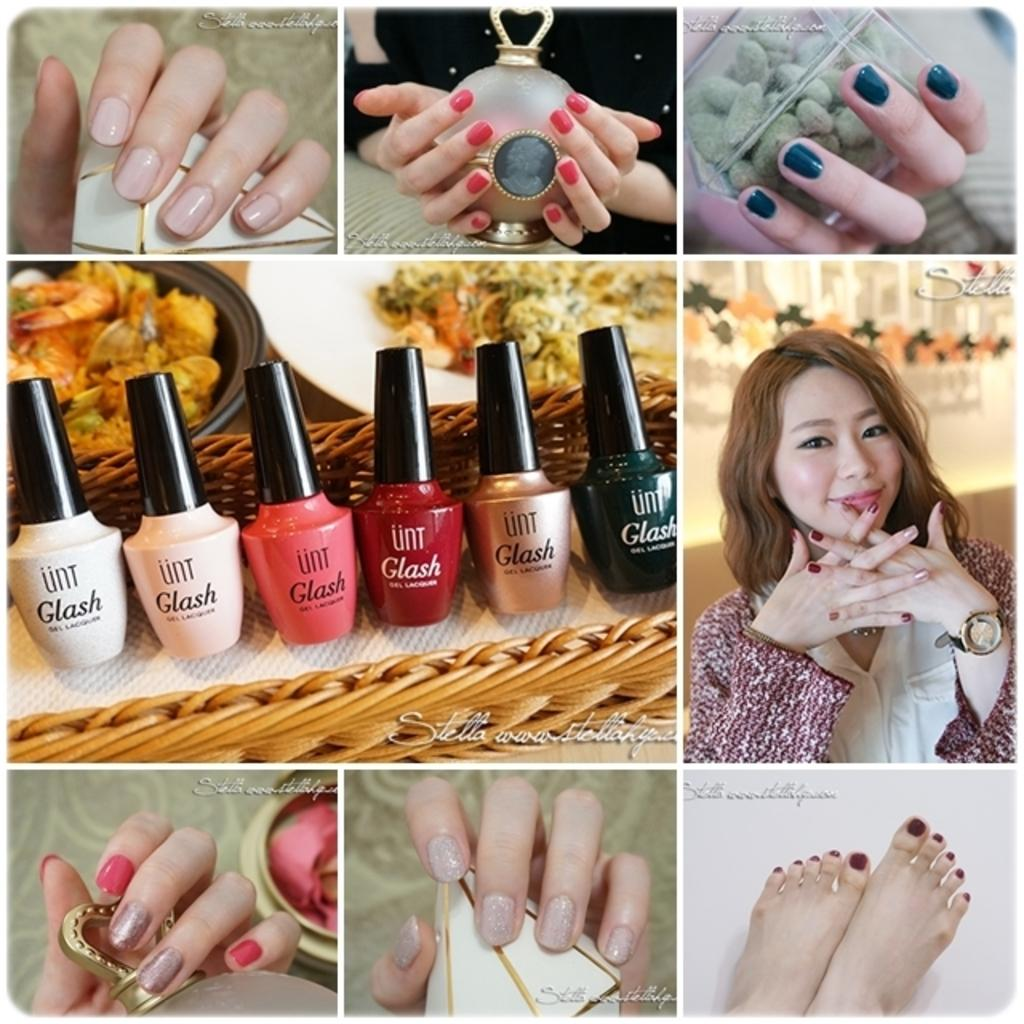What type of artwork is depicted in the image? The image is a collage. What items can be seen in the collage? There are nail polishes in the image. What activity is being performed in the image? There are persons applying nail polish to hands and legs in the image. What type of boot is being worn by the person applying nail polish to legs in the image? There is no boot visible in the image; the focus is on the application of nail polish to hands and legs. What theory is being discussed in the image? There is no discussion or mention of any theory in the image; it is focused on the application of nail polish. 